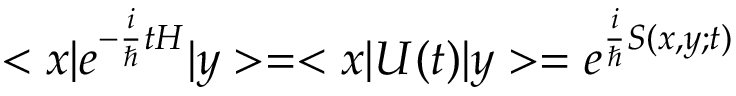<formula> <loc_0><loc_0><loc_500><loc_500>< x | e ^ { - { \frac { i } { } } t H } | y > = < x | U ( t ) | y > = e ^ { { \frac { i } { } } S ( x , y ; t ) }</formula> 